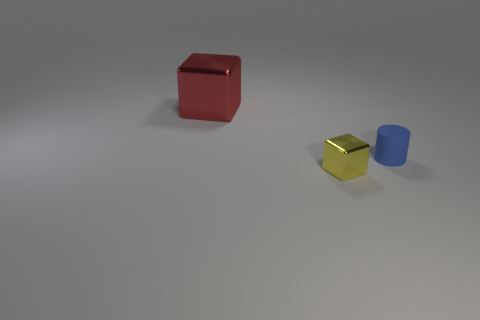Add 1 blue objects. How many objects exist? 4 Subtract all cylinders. How many objects are left? 2 Add 2 tiny purple rubber balls. How many tiny purple rubber balls exist? 2 Subtract 0 cyan cylinders. How many objects are left? 3 Subtract all big cyan shiny cylinders. Subtract all tiny metallic cubes. How many objects are left? 2 Add 2 tiny yellow blocks. How many tiny yellow blocks are left? 3 